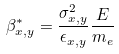Convert formula to latex. <formula><loc_0><loc_0><loc_500><loc_500>\beta ^ { * } _ { x , y } = \frac { \sigma _ { x , y } ^ { 2 } } { \epsilon _ { x , y } } \frac { E } { m _ { e } }</formula> 